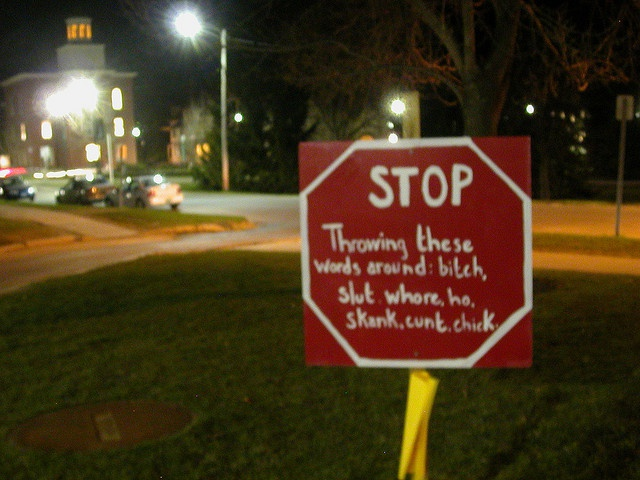Describe the objects in this image and their specific colors. I can see stop sign in black, maroon, darkgray, and gray tones, car in black, tan, darkgreen, gray, and ivory tones, car in black, olive, gray, and maroon tones, and car in black, gray, and darkgreen tones in this image. 